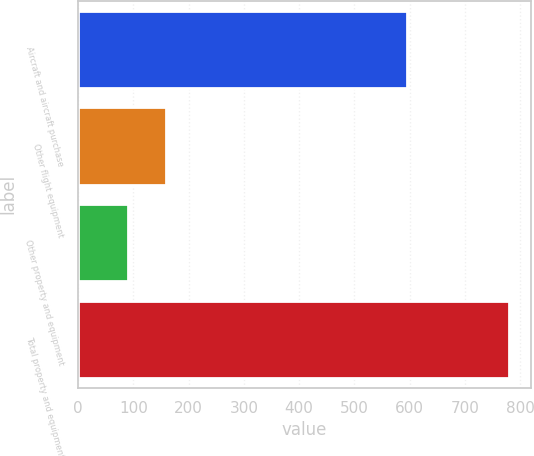Convert chart. <chart><loc_0><loc_0><loc_500><loc_500><bar_chart><fcel>Aircraft and aircraft purchase<fcel>Other flight equipment<fcel>Other property and equipment<fcel>Total property and equipment<nl><fcel>595<fcel>159<fcel>90<fcel>780<nl></chart> 